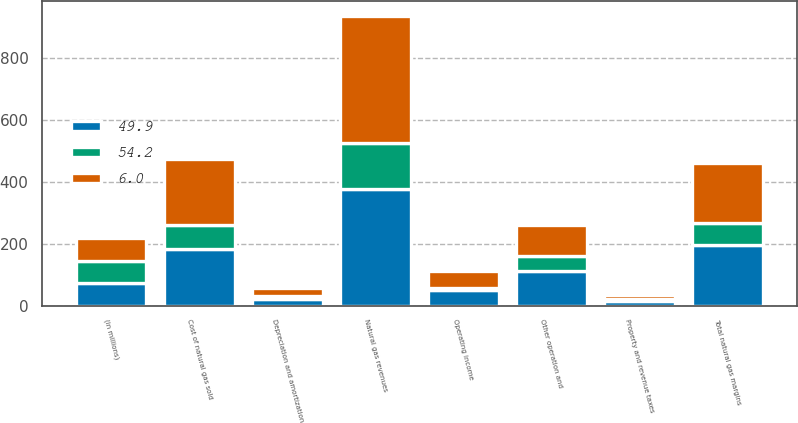Convert chart to OTSL. <chart><loc_0><loc_0><loc_500><loc_500><stacked_bar_chart><ecel><fcel>(in millions)<fcel>Natural gas revenues<fcel>Cost of natural gas sold<fcel>Total natural gas margins<fcel>Other operation and<fcel>Depreciation and amortization<fcel>Property and revenue taxes<fcel>Operating income<nl><fcel>6<fcel>72.4<fcel>411.2<fcel>215.3<fcel>195.9<fcel>101.3<fcel>24.8<fcel>15.6<fcel>54.2<nl><fcel>49.9<fcel>72.4<fcel>376.5<fcel>182.3<fcel>194.2<fcel>110.1<fcel>21.1<fcel>13.1<fcel>49.9<nl><fcel>54.2<fcel>72.4<fcel>149.3<fcel>76.9<fcel>72.4<fcel>50<fcel>10<fcel>6.4<fcel>6<nl></chart> 